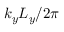Convert formula to latex. <formula><loc_0><loc_0><loc_500><loc_500>k _ { y } L _ { y } / 2 \pi</formula> 